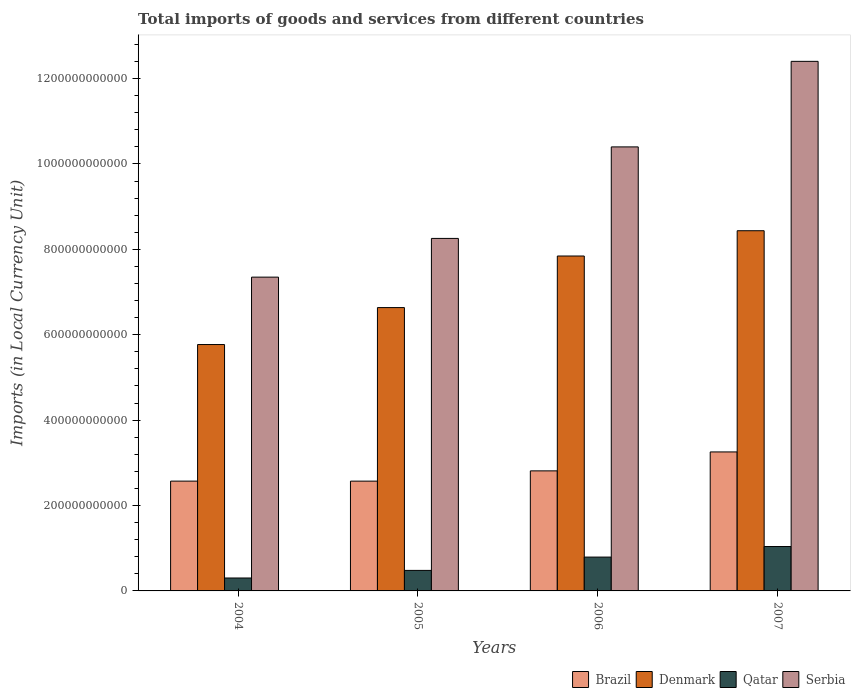How many bars are there on the 3rd tick from the right?
Your response must be concise. 4. In how many cases, is the number of bars for a given year not equal to the number of legend labels?
Keep it short and to the point. 0. What is the Amount of goods and services imports in Qatar in 2004?
Your answer should be compact. 3.03e+1. Across all years, what is the maximum Amount of goods and services imports in Qatar?
Provide a succinct answer. 1.04e+11. Across all years, what is the minimum Amount of goods and services imports in Brazil?
Ensure brevity in your answer.  2.57e+11. In which year was the Amount of goods and services imports in Brazil maximum?
Your answer should be very brief. 2007. In which year was the Amount of goods and services imports in Brazil minimum?
Your response must be concise. 2005. What is the total Amount of goods and services imports in Brazil in the graph?
Offer a very short reply. 1.12e+12. What is the difference between the Amount of goods and services imports in Qatar in 2004 and that in 2005?
Keep it short and to the point. -1.78e+1. What is the difference between the Amount of goods and services imports in Qatar in 2007 and the Amount of goods and services imports in Denmark in 2004?
Your answer should be very brief. -4.73e+11. What is the average Amount of goods and services imports in Brazil per year?
Offer a very short reply. 2.80e+11. In the year 2006, what is the difference between the Amount of goods and services imports in Serbia and Amount of goods and services imports in Denmark?
Offer a terse response. 2.56e+11. What is the ratio of the Amount of goods and services imports in Brazil in 2004 to that in 2006?
Your response must be concise. 0.91. Is the Amount of goods and services imports in Qatar in 2004 less than that in 2007?
Make the answer very short. Yes. What is the difference between the highest and the second highest Amount of goods and services imports in Denmark?
Offer a very short reply. 5.92e+1. What is the difference between the highest and the lowest Amount of goods and services imports in Brazil?
Offer a very short reply. 6.84e+1. In how many years, is the Amount of goods and services imports in Serbia greater than the average Amount of goods and services imports in Serbia taken over all years?
Offer a terse response. 2. Is the sum of the Amount of goods and services imports in Serbia in 2004 and 2005 greater than the maximum Amount of goods and services imports in Qatar across all years?
Your response must be concise. Yes. What does the 3rd bar from the left in 2007 represents?
Your answer should be compact. Qatar. Is it the case that in every year, the sum of the Amount of goods and services imports in Serbia and Amount of goods and services imports in Denmark is greater than the Amount of goods and services imports in Qatar?
Make the answer very short. Yes. How many bars are there?
Provide a succinct answer. 16. What is the difference between two consecutive major ticks on the Y-axis?
Your answer should be compact. 2.00e+11. Are the values on the major ticks of Y-axis written in scientific E-notation?
Provide a short and direct response. No. Does the graph contain grids?
Offer a very short reply. No. Where does the legend appear in the graph?
Offer a terse response. Bottom right. How many legend labels are there?
Offer a terse response. 4. How are the legend labels stacked?
Give a very brief answer. Horizontal. What is the title of the graph?
Your response must be concise. Total imports of goods and services from different countries. What is the label or title of the X-axis?
Your answer should be very brief. Years. What is the label or title of the Y-axis?
Give a very brief answer. Imports (in Local Currency Unit). What is the Imports (in Local Currency Unit) in Brazil in 2004?
Give a very brief answer. 2.57e+11. What is the Imports (in Local Currency Unit) of Denmark in 2004?
Your response must be concise. 5.77e+11. What is the Imports (in Local Currency Unit) in Qatar in 2004?
Make the answer very short. 3.03e+1. What is the Imports (in Local Currency Unit) in Serbia in 2004?
Ensure brevity in your answer.  7.35e+11. What is the Imports (in Local Currency Unit) in Brazil in 2005?
Provide a succinct answer. 2.57e+11. What is the Imports (in Local Currency Unit) of Denmark in 2005?
Offer a very short reply. 6.64e+11. What is the Imports (in Local Currency Unit) of Qatar in 2005?
Offer a terse response. 4.81e+1. What is the Imports (in Local Currency Unit) in Serbia in 2005?
Your answer should be compact. 8.26e+11. What is the Imports (in Local Currency Unit) in Brazil in 2006?
Make the answer very short. 2.81e+11. What is the Imports (in Local Currency Unit) in Denmark in 2006?
Ensure brevity in your answer.  7.84e+11. What is the Imports (in Local Currency Unit) in Qatar in 2006?
Provide a short and direct response. 7.92e+1. What is the Imports (in Local Currency Unit) of Serbia in 2006?
Provide a succinct answer. 1.04e+12. What is the Imports (in Local Currency Unit) of Brazil in 2007?
Provide a succinct answer. 3.26e+11. What is the Imports (in Local Currency Unit) of Denmark in 2007?
Give a very brief answer. 8.44e+11. What is the Imports (in Local Currency Unit) of Qatar in 2007?
Make the answer very short. 1.04e+11. What is the Imports (in Local Currency Unit) in Serbia in 2007?
Provide a short and direct response. 1.24e+12. Across all years, what is the maximum Imports (in Local Currency Unit) of Brazil?
Offer a very short reply. 3.26e+11. Across all years, what is the maximum Imports (in Local Currency Unit) of Denmark?
Your response must be concise. 8.44e+11. Across all years, what is the maximum Imports (in Local Currency Unit) of Qatar?
Ensure brevity in your answer.  1.04e+11. Across all years, what is the maximum Imports (in Local Currency Unit) in Serbia?
Your answer should be very brief. 1.24e+12. Across all years, what is the minimum Imports (in Local Currency Unit) in Brazil?
Give a very brief answer. 2.57e+11. Across all years, what is the minimum Imports (in Local Currency Unit) of Denmark?
Your answer should be compact. 5.77e+11. Across all years, what is the minimum Imports (in Local Currency Unit) of Qatar?
Provide a succinct answer. 3.03e+1. Across all years, what is the minimum Imports (in Local Currency Unit) of Serbia?
Your answer should be compact. 7.35e+11. What is the total Imports (in Local Currency Unit) of Brazil in the graph?
Ensure brevity in your answer.  1.12e+12. What is the total Imports (in Local Currency Unit) of Denmark in the graph?
Give a very brief answer. 2.87e+12. What is the total Imports (in Local Currency Unit) of Qatar in the graph?
Your response must be concise. 2.62e+11. What is the total Imports (in Local Currency Unit) in Serbia in the graph?
Offer a terse response. 3.84e+12. What is the difference between the Imports (in Local Currency Unit) in Brazil in 2004 and that in 2005?
Provide a short and direct response. 2.90e+07. What is the difference between the Imports (in Local Currency Unit) of Denmark in 2004 and that in 2005?
Give a very brief answer. -8.65e+1. What is the difference between the Imports (in Local Currency Unit) of Qatar in 2004 and that in 2005?
Give a very brief answer. -1.78e+1. What is the difference between the Imports (in Local Currency Unit) in Serbia in 2004 and that in 2005?
Give a very brief answer. -9.07e+1. What is the difference between the Imports (in Local Currency Unit) of Brazil in 2004 and that in 2006?
Provide a short and direct response. -2.40e+1. What is the difference between the Imports (in Local Currency Unit) of Denmark in 2004 and that in 2006?
Your answer should be compact. -2.07e+11. What is the difference between the Imports (in Local Currency Unit) in Qatar in 2004 and that in 2006?
Ensure brevity in your answer.  -4.90e+1. What is the difference between the Imports (in Local Currency Unit) of Serbia in 2004 and that in 2006?
Your answer should be compact. -3.05e+11. What is the difference between the Imports (in Local Currency Unit) of Brazil in 2004 and that in 2007?
Your response must be concise. -6.84e+1. What is the difference between the Imports (in Local Currency Unit) of Denmark in 2004 and that in 2007?
Ensure brevity in your answer.  -2.67e+11. What is the difference between the Imports (in Local Currency Unit) of Qatar in 2004 and that in 2007?
Make the answer very short. -7.37e+1. What is the difference between the Imports (in Local Currency Unit) of Serbia in 2004 and that in 2007?
Offer a very short reply. -5.05e+11. What is the difference between the Imports (in Local Currency Unit) of Brazil in 2005 and that in 2006?
Your answer should be very brief. -2.41e+1. What is the difference between the Imports (in Local Currency Unit) of Denmark in 2005 and that in 2006?
Make the answer very short. -1.21e+11. What is the difference between the Imports (in Local Currency Unit) in Qatar in 2005 and that in 2006?
Make the answer very short. -3.12e+1. What is the difference between the Imports (in Local Currency Unit) in Serbia in 2005 and that in 2006?
Your answer should be compact. -2.14e+11. What is the difference between the Imports (in Local Currency Unit) of Brazil in 2005 and that in 2007?
Your answer should be very brief. -6.84e+1. What is the difference between the Imports (in Local Currency Unit) in Denmark in 2005 and that in 2007?
Provide a short and direct response. -1.80e+11. What is the difference between the Imports (in Local Currency Unit) of Qatar in 2005 and that in 2007?
Make the answer very short. -5.59e+1. What is the difference between the Imports (in Local Currency Unit) of Serbia in 2005 and that in 2007?
Provide a short and direct response. -4.15e+11. What is the difference between the Imports (in Local Currency Unit) in Brazil in 2006 and that in 2007?
Your answer should be very brief. -4.43e+1. What is the difference between the Imports (in Local Currency Unit) in Denmark in 2006 and that in 2007?
Keep it short and to the point. -5.92e+1. What is the difference between the Imports (in Local Currency Unit) of Qatar in 2006 and that in 2007?
Ensure brevity in your answer.  -2.47e+1. What is the difference between the Imports (in Local Currency Unit) in Serbia in 2006 and that in 2007?
Provide a succinct answer. -2.00e+11. What is the difference between the Imports (in Local Currency Unit) in Brazil in 2004 and the Imports (in Local Currency Unit) in Denmark in 2005?
Your response must be concise. -4.06e+11. What is the difference between the Imports (in Local Currency Unit) in Brazil in 2004 and the Imports (in Local Currency Unit) in Qatar in 2005?
Ensure brevity in your answer.  2.09e+11. What is the difference between the Imports (in Local Currency Unit) of Brazil in 2004 and the Imports (in Local Currency Unit) of Serbia in 2005?
Provide a succinct answer. -5.68e+11. What is the difference between the Imports (in Local Currency Unit) of Denmark in 2004 and the Imports (in Local Currency Unit) of Qatar in 2005?
Offer a very short reply. 5.29e+11. What is the difference between the Imports (in Local Currency Unit) in Denmark in 2004 and the Imports (in Local Currency Unit) in Serbia in 2005?
Make the answer very short. -2.49e+11. What is the difference between the Imports (in Local Currency Unit) of Qatar in 2004 and the Imports (in Local Currency Unit) of Serbia in 2005?
Keep it short and to the point. -7.95e+11. What is the difference between the Imports (in Local Currency Unit) in Brazil in 2004 and the Imports (in Local Currency Unit) in Denmark in 2006?
Ensure brevity in your answer.  -5.27e+11. What is the difference between the Imports (in Local Currency Unit) in Brazil in 2004 and the Imports (in Local Currency Unit) in Qatar in 2006?
Your answer should be very brief. 1.78e+11. What is the difference between the Imports (in Local Currency Unit) of Brazil in 2004 and the Imports (in Local Currency Unit) of Serbia in 2006?
Your response must be concise. -7.83e+11. What is the difference between the Imports (in Local Currency Unit) of Denmark in 2004 and the Imports (in Local Currency Unit) of Qatar in 2006?
Give a very brief answer. 4.98e+11. What is the difference between the Imports (in Local Currency Unit) of Denmark in 2004 and the Imports (in Local Currency Unit) of Serbia in 2006?
Give a very brief answer. -4.63e+11. What is the difference between the Imports (in Local Currency Unit) of Qatar in 2004 and the Imports (in Local Currency Unit) of Serbia in 2006?
Ensure brevity in your answer.  -1.01e+12. What is the difference between the Imports (in Local Currency Unit) of Brazil in 2004 and the Imports (in Local Currency Unit) of Denmark in 2007?
Give a very brief answer. -5.86e+11. What is the difference between the Imports (in Local Currency Unit) of Brazil in 2004 and the Imports (in Local Currency Unit) of Qatar in 2007?
Ensure brevity in your answer.  1.53e+11. What is the difference between the Imports (in Local Currency Unit) of Brazil in 2004 and the Imports (in Local Currency Unit) of Serbia in 2007?
Offer a terse response. -9.83e+11. What is the difference between the Imports (in Local Currency Unit) in Denmark in 2004 and the Imports (in Local Currency Unit) in Qatar in 2007?
Make the answer very short. 4.73e+11. What is the difference between the Imports (in Local Currency Unit) of Denmark in 2004 and the Imports (in Local Currency Unit) of Serbia in 2007?
Make the answer very short. -6.63e+11. What is the difference between the Imports (in Local Currency Unit) in Qatar in 2004 and the Imports (in Local Currency Unit) in Serbia in 2007?
Offer a very short reply. -1.21e+12. What is the difference between the Imports (in Local Currency Unit) of Brazil in 2005 and the Imports (in Local Currency Unit) of Denmark in 2006?
Provide a succinct answer. -5.27e+11. What is the difference between the Imports (in Local Currency Unit) of Brazil in 2005 and the Imports (in Local Currency Unit) of Qatar in 2006?
Your response must be concise. 1.78e+11. What is the difference between the Imports (in Local Currency Unit) of Brazil in 2005 and the Imports (in Local Currency Unit) of Serbia in 2006?
Provide a short and direct response. -7.83e+11. What is the difference between the Imports (in Local Currency Unit) of Denmark in 2005 and the Imports (in Local Currency Unit) of Qatar in 2006?
Provide a succinct answer. 5.84e+11. What is the difference between the Imports (in Local Currency Unit) of Denmark in 2005 and the Imports (in Local Currency Unit) of Serbia in 2006?
Provide a short and direct response. -3.76e+11. What is the difference between the Imports (in Local Currency Unit) in Qatar in 2005 and the Imports (in Local Currency Unit) in Serbia in 2006?
Give a very brief answer. -9.92e+11. What is the difference between the Imports (in Local Currency Unit) in Brazil in 2005 and the Imports (in Local Currency Unit) in Denmark in 2007?
Offer a very short reply. -5.86e+11. What is the difference between the Imports (in Local Currency Unit) of Brazil in 2005 and the Imports (in Local Currency Unit) of Qatar in 2007?
Give a very brief answer. 1.53e+11. What is the difference between the Imports (in Local Currency Unit) in Brazil in 2005 and the Imports (in Local Currency Unit) in Serbia in 2007?
Provide a succinct answer. -9.83e+11. What is the difference between the Imports (in Local Currency Unit) of Denmark in 2005 and the Imports (in Local Currency Unit) of Qatar in 2007?
Your answer should be compact. 5.60e+11. What is the difference between the Imports (in Local Currency Unit) in Denmark in 2005 and the Imports (in Local Currency Unit) in Serbia in 2007?
Offer a very short reply. -5.77e+11. What is the difference between the Imports (in Local Currency Unit) in Qatar in 2005 and the Imports (in Local Currency Unit) in Serbia in 2007?
Your answer should be compact. -1.19e+12. What is the difference between the Imports (in Local Currency Unit) of Brazil in 2006 and the Imports (in Local Currency Unit) of Denmark in 2007?
Provide a short and direct response. -5.62e+11. What is the difference between the Imports (in Local Currency Unit) of Brazil in 2006 and the Imports (in Local Currency Unit) of Qatar in 2007?
Offer a very short reply. 1.77e+11. What is the difference between the Imports (in Local Currency Unit) in Brazil in 2006 and the Imports (in Local Currency Unit) in Serbia in 2007?
Provide a short and direct response. -9.59e+11. What is the difference between the Imports (in Local Currency Unit) in Denmark in 2006 and the Imports (in Local Currency Unit) in Qatar in 2007?
Provide a succinct answer. 6.80e+11. What is the difference between the Imports (in Local Currency Unit) in Denmark in 2006 and the Imports (in Local Currency Unit) in Serbia in 2007?
Ensure brevity in your answer.  -4.56e+11. What is the difference between the Imports (in Local Currency Unit) of Qatar in 2006 and the Imports (in Local Currency Unit) of Serbia in 2007?
Your answer should be very brief. -1.16e+12. What is the average Imports (in Local Currency Unit) in Brazil per year?
Make the answer very short. 2.80e+11. What is the average Imports (in Local Currency Unit) of Denmark per year?
Keep it short and to the point. 7.17e+11. What is the average Imports (in Local Currency Unit) of Qatar per year?
Provide a succinct answer. 6.54e+1. What is the average Imports (in Local Currency Unit) of Serbia per year?
Give a very brief answer. 9.60e+11. In the year 2004, what is the difference between the Imports (in Local Currency Unit) in Brazil and Imports (in Local Currency Unit) in Denmark?
Ensure brevity in your answer.  -3.20e+11. In the year 2004, what is the difference between the Imports (in Local Currency Unit) of Brazil and Imports (in Local Currency Unit) of Qatar?
Provide a short and direct response. 2.27e+11. In the year 2004, what is the difference between the Imports (in Local Currency Unit) in Brazil and Imports (in Local Currency Unit) in Serbia?
Your response must be concise. -4.78e+11. In the year 2004, what is the difference between the Imports (in Local Currency Unit) in Denmark and Imports (in Local Currency Unit) in Qatar?
Offer a terse response. 5.47e+11. In the year 2004, what is the difference between the Imports (in Local Currency Unit) of Denmark and Imports (in Local Currency Unit) of Serbia?
Give a very brief answer. -1.58e+11. In the year 2004, what is the difference between the Imports (in Local Currency Unit) in Qatar and Imports (in Local Currency Unit) in Serbia?
Your answer should be compact. -7.05e+11. In the year 2005, what is the difference between the Imports (in Local Currency Unit) in Brazil and Imports (in Local Currency Unit) in Denmark?
Your answer should be very brief. -4.06e+11. In the year 2005, what is the difference between the Imports (in Local Currency Unit) in Brazil and Imports (in Local Currency Unit) in Qatar?
Your answer should be compact. 2.09e+11. In the year 2005, what is the difference between the Imports (in Local Currency Unit) of Brazil and Imports (in Local Currency Unit) of Serbia?
Keep it short and to the point. -5.68e+11. In the year 2005, what is the difference between the Imports (in Local Currency Unit) of Denmark and Imports (in Local Currency Unit) of Qatar?
Make the answer very short. 6.15e+11. In the year 2005, what is the difference between the Imports (in Local Currency Unit) of Denmark and Imports (in Local Currency Unit) of Serbia?
Keep it short and to the point. -1.62e+11. In the year 2005, what is the difference between the Imports (in Local Currency Unit) of Qatar and Imports (in Local Currency Unit) of Serbia?
Give a very brief answer. -7.78e+11. In the year 2006, what is the difference between the Imports (in Local Currency Unit) of Brazil and Imports (in Local Currency Unit) of Denmark?
Your answer should be very brief. -5.03e+11. In the year 2006, what is the difference between the Imports (in Local Currency Unit) in Brazil and Imports (in Local Currency Unit) in Qatar?
Offer a terse response. 2.02e+11. In the year 2006, what is the difference between the Imports (in Local Currency Unit) of Brazil and Imports (in Local Currency Unit) of Serbia?
Your response must be concise. -7.59e+11. In the year 2006, what is the difference between the Imports (in Local Currency Unit) in Denmark and Imports (in Local Currency Unit) in Qatar?
Ensure brevity in your answer.  7.05e+11. In the year 2006, what is the difference between the Imports (in Local Currency Unit) in Denmark and Imports (in Local Currency Unit) in Serbia?
Make the answer very short. -2.56e+11. In the year 2006, what is the difference between the Imports (in Local Currency Unit) of Qatar and Imports (in Local Currency Unit) of Serbia?
Your answer should be very brief. -9.61e+11. In the year 2007, what is the difference between the Imports (in Local Currency Unit) in Brazil and Imports (in Local Currency Unit) in Denmark?
Keep it short and to the point. -5.18e+11. In the year 2007, what is the difference between the Imports (in Local Currency Unit) in Brazil and Imports (in Local Currency Unit) in Qatar?
Provide a succinct answer. 2.22e+11. In the year 2007, what is the difference between the Imports (in Local Currency Unit) of Brazil and Imports (in Local Currency Unit) of Serbia?
Make the answer very short. -9.15e+11. In the year 2007, what is the difference between the Imports (in Local Currency Unit) of Denmark and Imports (in Local Currency Unit) of Qatar?
Your answer should be very brief. 7.40e+11. In the year 2007, what is the difference between the Imports (in Local Currency Unit) of Denmark and Imports (in Local Currency Unit) of Serbia?
Provide a succinct answer. -3.97e+11. In the year 2007, what is the difference between the Imports (in Local Currency Unit) in Qatar and Imports (in Local Currency Unit) in Serbia?
Your answer should be very brief. -1.14e+12. What is the ratio of the Imports (in Local Currency Unit) of Denmark in 2004 to that in 2005?
Provide a short and direct response. 0.87. What is the ratio of the Imports (in Local Currency Unit) in Qatar in 2004 to that in 2005?
Ensure brevity in your answer.  0.63. What is the ratio of the Imports (in Local Currency Unit) in Serbia in 2004 to that in 2005?
Your answer should be very brief. 0.89. What is the ratio of the Imports (in Local Currency Unit) of Brazil in 2004 to that in 2006?
Keep it short and to the point. 0.91. What is the ratio of the Imports (in Local Currency Unit) of Denmark in 2004 to that in 2006?
Offer a very short reply. 0.74. What is the ratio of the Imports (in Local Currency Unit) of Qatar in 2004 to that in 2006?
Ensure brevity in your answer.  0.38. What is the ratio of the Imports (in Local Currency Unit) in Serbia in 2004 to that in 2006?
Make the answer very short. 0.71. What is the ratio of the Imports (in Local Currency Unit) of Brazil in 2004 to that in 2007?
Offer a very short reply. 0.79. What is the ratio of the Imports (in Local Currency Unit) in Denmark in 2004 to that in 2007?
Provide a short and direct response. 0.68. What is the ratio of the Imports (in Local Currency Unit) of Qatar in 2004 to that in 2007?
Give a very brief answer. 0.29. What is the ratio of the Imports (in Local Currency Unit) in Serbia in 2004 to that in 2007?
Give a very brief answer. 0.59. What is the ratio of the Imports (in Local Currency Unit) in Brazil in 2005 to that in 2006?
Ensure brevity in your answer.  0.91. What is the ratio of the Imports (in Local Currency Unit) in Denmark in 2005 to that in 2006?
Your response must be concise. 0.85. What is the ratio of the Imports (in Local Currency Unit) of Qatar in 2005 to that in 2006?
Ensure brevity in your answer.  0.61. What is the ratio of the Imports (in Local Currency Unit) in Serbia in 2005 to that in 2006?
Offer a terse response. 0.79. What is the ratio of the Imports (in Local Currency Unit) of Brazil in 2005 to that in 2007?
Your answer should be very brief. 0.79. What is the ratio of the Imports (in Local Currency Unit) in Denmark in 2005 to that in 2007?
Ensure brevity in your answer.  0.79. What is the ratio of the Imports (in Local Currency Unit) in Qatar in 2005 to that in 2007?
Ensure brevity in your answer.  0.46. What is the ratio of the Imports (in Local Currency Unit) of Serbia in 2005 to that in 2007?
Offer a terse response. 0.67. What is the ratio of the Imports (in Local Currency Unit) in Brazil in 2006 to that in 2007?
Your answer should be very brief. 0.86. What is the ratio of the Imports (in Local Currency Unit) of Denmark in 2006 to that in 2007?
Ensure brevity in your answer.  0.93. What is the ratio of the Imports (in Local Currency Unit) in Qatar in 2006 to that in 2007?
Your answer should be very brief. 0.76. What is the ratio of the Imports (in Local Currency Unit) of Serbia in 2006 to that in 2007?
Provide a short and direct response. 0.84. What is the difference between the highest and the second highest Imports (in Local Currency Unit) in Brazil?
Give a very brief answer. 4.43e+1. What is the difference between the highest and the second highest Imports (in Local Currency Unit) in Denmark?
Your response must be concise. 5.92e+1. What is the difference between the highest and the second highest Imports (in Local Currency Unit) in Qatar?
Provide a succinct answer. 2.47e+1. What is the difference between the highest and the second highest Imports (in Local Currency Unit) in Serbia?
Make the answer very short. 2.00e+11. What is the difference between the highest and the lowest Imports (in Local Currency Unit) of Brazil?
Keep it short and to the point. 6.84e+1. What is the difference between the highest and the lowest Imports (in Local Currency Unit) of Denmark?
Your answer should be very brief. 2.67e+11. What is the difference between the highest and the lowest Imports (in Local Currency Unit) of Qatar?
Offer a very short reply. 7.37e+1. What is the difference between the highest and the lowest Imports (in Local Currency Unit) in Serbia?
Provide a short and direct response. 5.05e+11. 